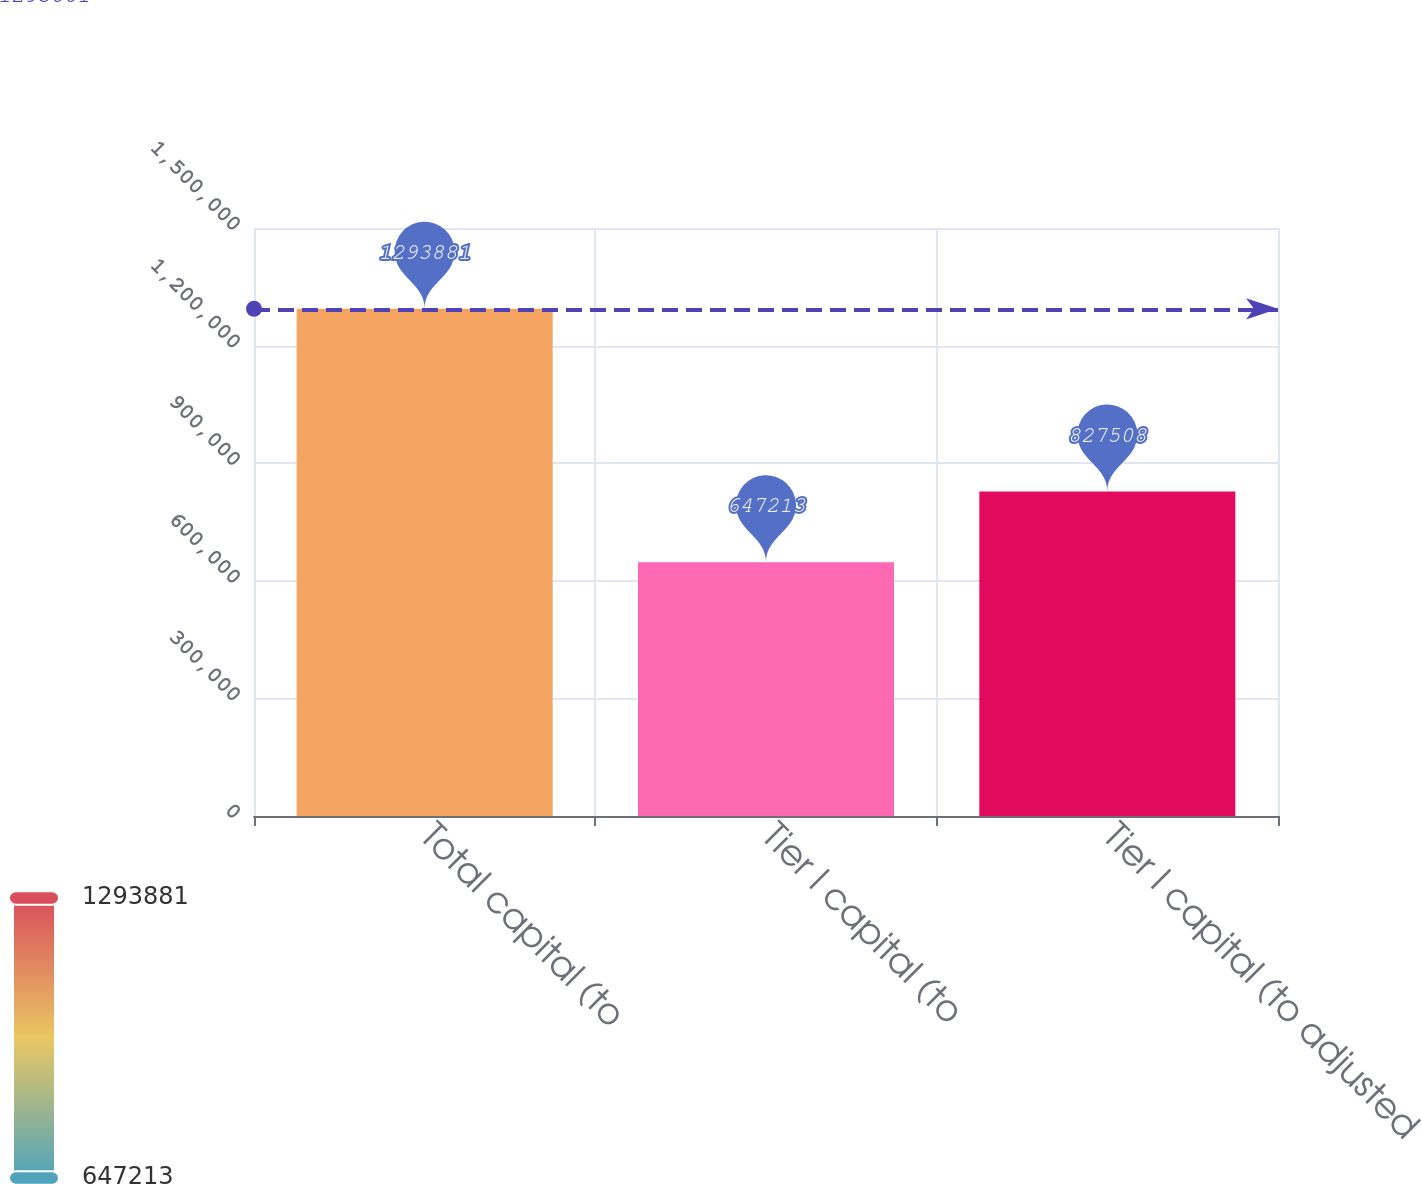Convert chart. <chart><loc_0><loc_0><loc_500><loc_500><bar_chart><fcel>Total capital (to<fcel>Tier I capital (to<fcel>Tier I capital (to adjusted<nl><fcel>1.29388e+06<fcel>647213<fcel>827508<nl></chart> 